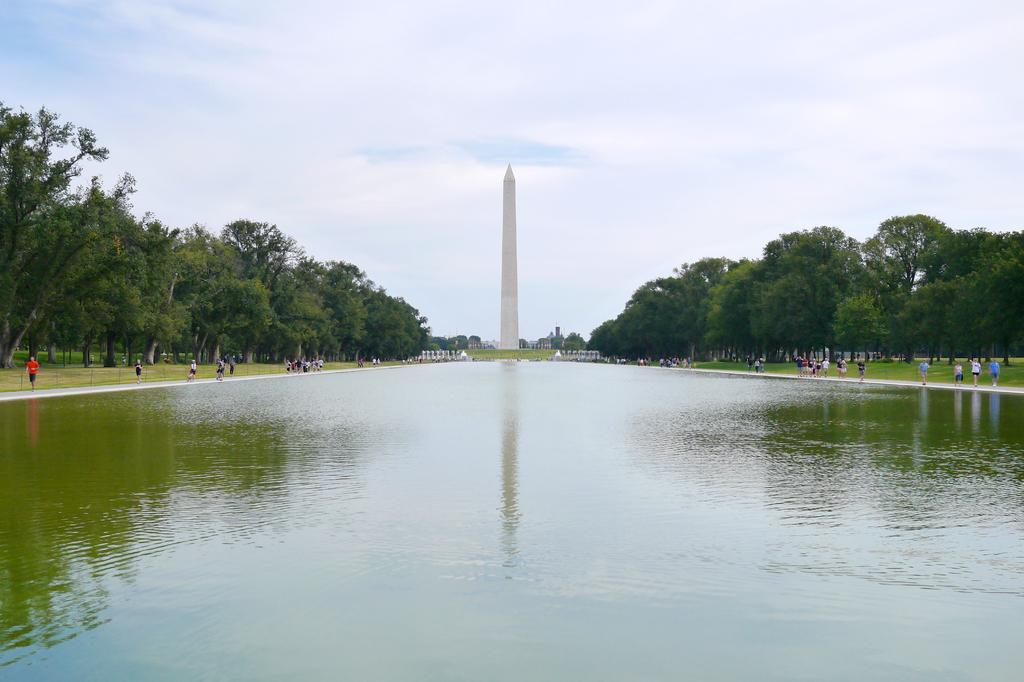Describe this image in one or two sentences. In this image, we can see a lake in between trees. There are some persons on the left and on the right side of the image. There is a tower in the middle of the image. In the background of the image, there is a sky. 